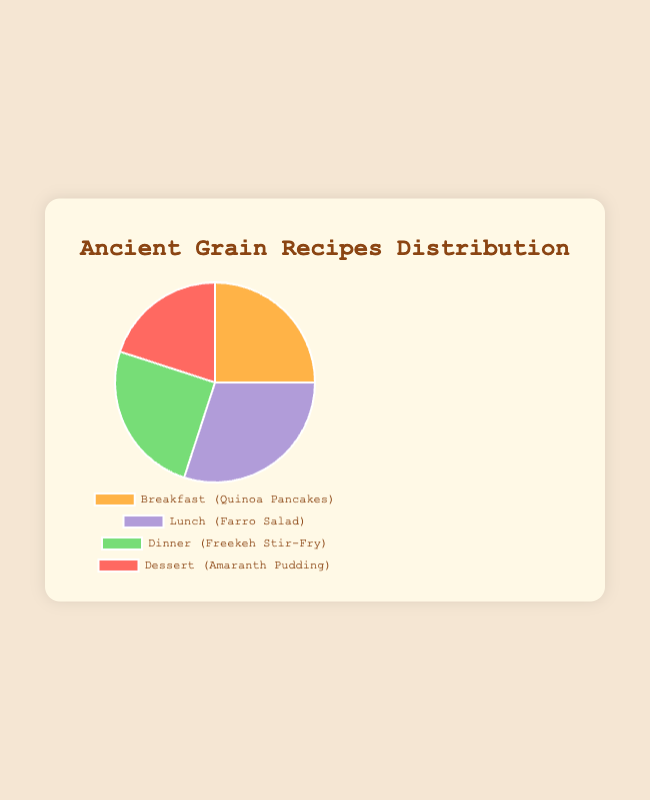What percentage of the recipes are for lunch? The label for the lunch segment indicates that it has 30% of the recipes.
Answer: 30% What is the difference between the percentage of breakfast and dessert recipes? The breakfast recipes account for 25% and dessert recipes account for 20%. The difference is 25% - 20% = 5%.
Answer: 5% Which type of recipe has the smallest percentage? The segment with the smallest percentage is the Dessert (Amaranth Pudding) part, which is 20%.
Answer: Dessert Are there more breakfast or dinner recipes, and by how much? Both breakfast and dinner recipes have the same percentage, 25%.
Answer: They are the same What percentage of recipes are not dinner recipes? The percentage of dinner recipes is 25%. So, the percentage of non-dinner recipes is 100% - 25% = 75%.
Answer: 75% Which recipe type has the second-highest percentage? The segment labeled Lunch (Farro Salad) has 30%. The next highest segment is Breakfast (Quinoa Pancakes) and Dinner (Freekeh Stir-Fry), both with 25%.
Answer: Breakfast and Dinner What is the total percentage of breakfast and dinner recipes combined? The percentages for breakfast are 25% and dinner are 25%. Combined, it is 25% + 25% = 50%.
Answer: 50% How many more percentage points are lunch recipes compared to dessert recipes? The percentage for lunch is 30% and for dessert is 20%. The difference is 30% - 20% = 10%.
Answer: 10% If you were to combine the breakfast and lunch recipes, what percentage would that be? The percentage for breakfast is 25% and for lunch is 30%. Combined, it would be 25% + 30% = 55%.
Answer: 55% Which type of recipe has the same percentage value as breakfast recipes? The segment for dinner (Freekeh Stir-Fry) also has a percentage of 25%, which is the same as the breakfast recipes.
Answer: Dinner 